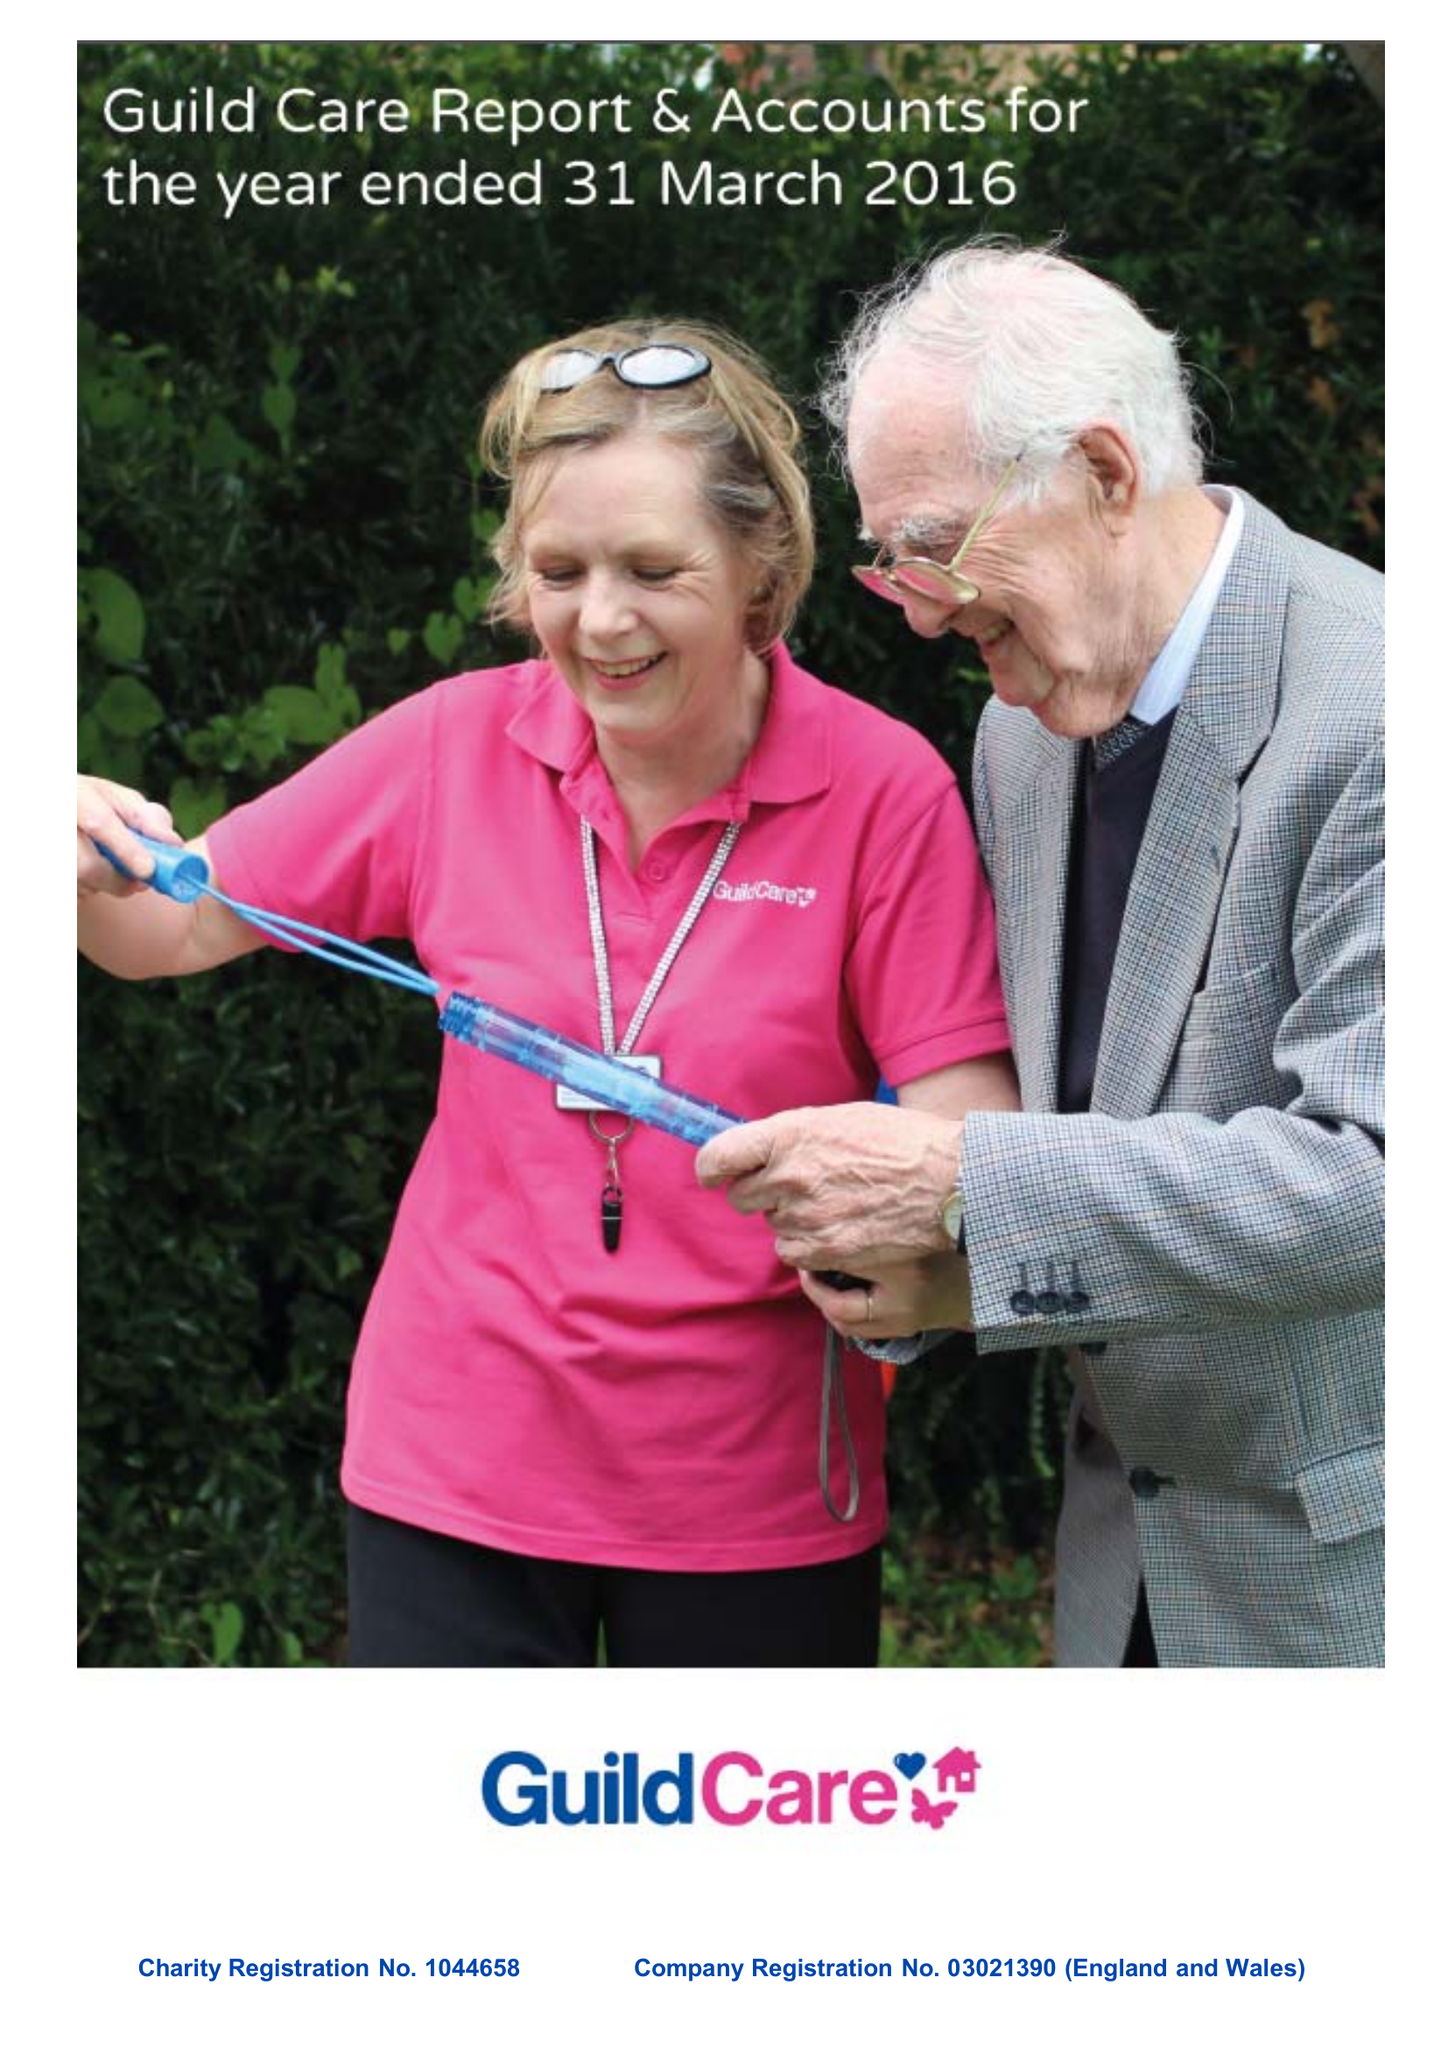What is the value for the address__street_line?
Answer the question using a single word or phrase. NORTH STREET 